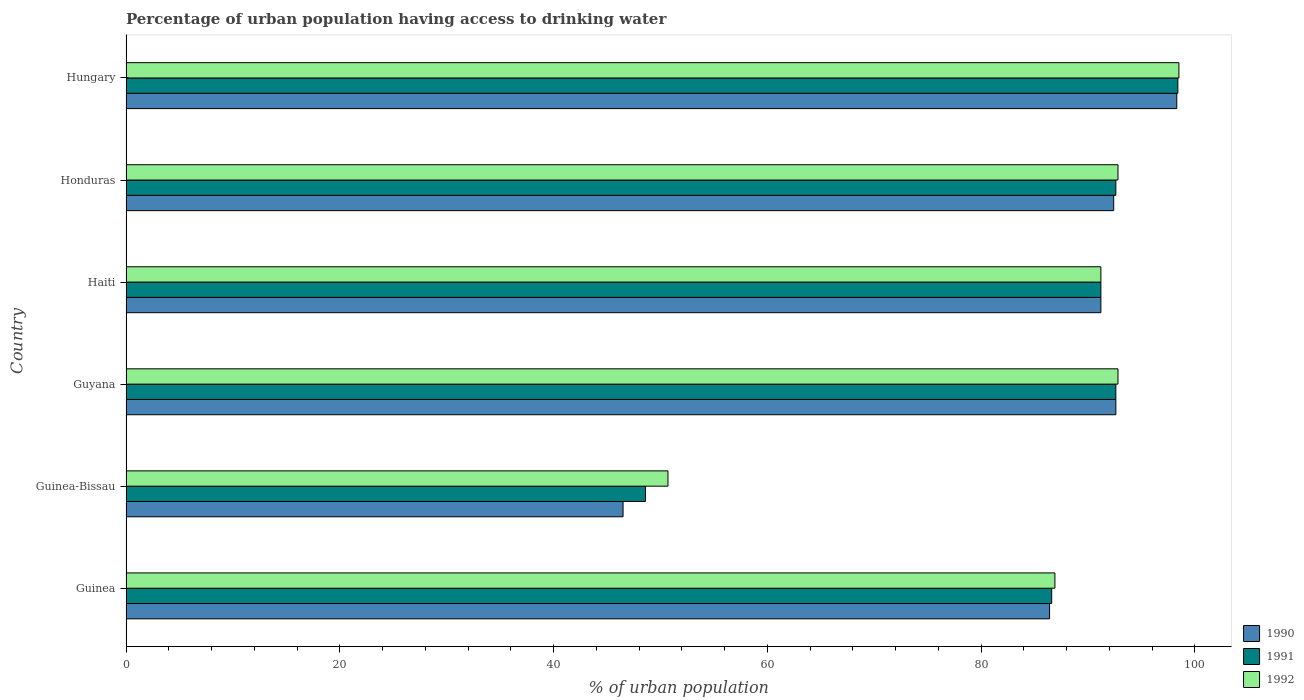How many groups of bars are there?
Your answer should be very brief. 6. Are the number of bars on each tick of the Y-axis equal?
Provide a succinct answer. Yes. What is the label of the 4th group of bars from the top?
Make the answer very short. Guyana. In how many cases, is the number of bars for a given country not equal to the number of legend labels?
Provide a succinct answer. 0. What is the percentage of urban population having access to drinking water in 1990 in Guinea?
Ensure brevity in your answer.  86.4. Across all countries, what is the maximum percentage of urban population having access to drinking water in 1991?
Offer a very short reply. 98.4. Across all countries, what is the minimum percentage of urban population having access to drinking water in 1990?
Provide a short and direct response. 46.5. In which country was the percentage of urban population having access to drinking water in 1991 maximum?
Make the answer very short. Hungary. In which country was the percentage of urban population having access to drinking water in 1990 minimum?
Your response must be concise. Guinea-Bissau. What is the total percentage of urban population having access to drinking water in 1991 in the graph?
Make the answer very short. 510. What is the difference between the percentage of urban population having access to drinking water in 1991 in Guinea and that in Honduras?
Your answer should be very brief. -6. What is the difference between the percentage of urban population having access to drinking water in 1990 in Guinea-Bissau and the percentage of urban population having access to drinking water in 1991 in Haiti?
Ensure brevity in your answer.  -44.7. What is the average percentage of urban population having access to drinking water in 1992 per country?
Your answer should be very brief. 85.48. In how many countries, is the percentage of urban population having access to drinking water in 1990 greater than 48 %?
Give a very brief answer. 5. What is the ratio of the percentage of urban population having access to drinking water in 1991 in Guinea-Bissau to that in Honduras?
Your response must be concise. 0.52. What is the difference between the highest and the second highest percentage of urban population having access to drinking water in 1991?
Ensure brevity in your answer.  5.8. What is the difference between the highest and the lowest percentage of urban population having access to drinking water in 1990?
Provide a succinct answer. 51.8. In how many countries, is the percentage of urban population having access to drinking water in 1991 greater than the average percentage of urban population having access to drinking water in 1991 taken over all countries?
Your response must be concise. 5. Is the sum of the percentage of urban population having access to drinking water in 1990 in Guinea-Bissau and Guyana greater than the maximum percentage of urban population having access to drinking water in 1991 across all countries?
Your answer should be very brief. Yes. What does the 2nd bar from the top in Haiti represents?
Make the answer very short. 1991. Are all the bars in the graph horizontal?
Your answer should be very brief. Yes. How many countries are there in the graph?
Your answer should be compact. 6. Are the values on the major ticks of X-axis written in scientific E-notation?
Your answer should be very brief. No. Does the graph contain any zero values?
Give a very brief answer. No. Does the graph contain grids?
Your response must be concise. No. How are the legend labels stacked?
Keep it short and to the point. Vertical. What is the title of the graph?
Your answer should be very brief. Percentage of urban population having access to drinking water. What is the label or title of the X-axis?
Your answer should be compact. % of urban population. What is the % of urban population of 1990 in Guinea?
Provide a succinct answer. 86.4. What is the % of urban population in 1991 in Guinea?
Offer a very short reply. 86.6. What is the % of urban population of 1992 in Guinea?
Your answer should be compact. 86.9. What is the % of urban population in 1990 in Guinea-Bissau?
Offer a very short reply. 46.5. What is the % of urban population of 1991 in Guinea-Bissau?
Provide a succinct answer. 48.6. What is the % of urban population of 1992 in Guinea-Bissau?
Give a very brief answer. 50.7. What is the % of urban population of 1990 in Guyana?
Give a very brief answer. 92.6. What is the % of urban population of 1991 in Guyana?
Your response must be concise. 92.6. What is the % of urban population in 1992 in Guyana?
Offer a very short reply. 92.8. What is the % of urban population in 1990 in Haiti?
Ensure brevity in your answer.  91.2. What is the % of urban population of 1991 in Haiti?
Your response must be concise. 91.2. What is the % of urban population of 1992 in Haiti?
Give a very brief answer. 91.2. What is the % of urban population in 1990 in Honduras?
Your answer should be very brief. 92.4. What is the % of urban population of 1991 in Honduras?
Offer a very short reply. 92.6. What is the % of urban population of 1992 in Honduras?
Your answer should be compact. 92.8. What is the % of urban population of 1990 in Hungary?
Give a very brief answer. 98.3. What is the % of urban population of 1991 in Hungary?
Your answer should be very brief. 98.4. What is the % of urban population of 1992 in Hungary?
Provide a short and direct response. 98.5. Across all countries, what is the maximum % of urban population of 1990?
Your answer should be compact. 98.3. Across all countries, what is the maximum % of urban population of 1991?
Offer a very short reply. 98.4. Across all countries, what is the maximum % of urban population of 1992?
Keep it short and to the point. 98.5. Across all countries, what is the minimum % of urban population of 1990?
Provide a succinct answer. 46.5. Across all countries, what is the minimum % of urban population in 1991?
Offer a terse response. 48.6. Across all countries, what is the minimum % of urban population in 1992?
Offer a terse response. 50.7. What is the total % of urban population in 1990 in the graph?
Provide a short and direct response. 507.4. What is the total % of urban population of 1991 in the graph?
Make the answer very short. 510. What is the total % of urban population of 1992 in the graph?
Give a very brief answer. 512.9. What is the difference between the % of urban population of 1990 in Guinea and that in Guinea-Bissau?
Ensure brevity in your answer.  39.9. What is the difference between the % of urban population of 1992 in Guinea and that in Guinea-Bissau?
Keep it short and to the point. 36.2. What is the difference between the % of urban population in 1991 in Guinea and that in Guyana?
Keep it short and to the point. -6. What is the difference between the % of urban population of 1992 in Guinea and that in Haiti?
Make the answer very short. -4.3. What is the difference between the % of urban population of 1991 in Guinea and that in Hungary?
Keep it short and to the point. -11.8. What is the difference between the % of urban population in 1992 in Guinea and that in Hungary?
Your answer should be compact. -11.6. What is the difference between the % of urban population in 1990 in Guinea-Bissau and that in Guyana?
Offer a terse response. -46.1. What is the difference between the % of urban population in 1991 in Guinea-Bissau and that in Guyana?
Keep it short and to the point. -44. What is the difference between the % of urban population in 1992 in Guinea-Bissau and that in Guyana?
Your answer should be very brief. -42.1. What is the difference between the % of urban population of 1990 in Guinea-Bissau and that in Haiti?
Your response must be concise. -44.7. What is the difference between the % of urban population of 1991 in Guinea-Bissau and that in Haiti?
Make the answer very short. -42.6. What is the difference between the % of urban population in 1992 in Guinea-Bissau and that in Haiti?
Your answer should be very brief. -40.5. What is the difference between the % of urban population of 1990 in Guinea-Bissau and that in Honduras?
Offer a very short reply. -45.9. What is the difference between the % of urban population in 1991 in Guinea-Bissau and that in Honduras?
Provide a short and direct response. -44. What is the difference between the % of urban population in 1992 in Guinea-Bissau and that in Honduras?
Your answer should be very brief. -42.1. What is the difference between the % of urban population of 1990 in Guinea-Bissau and that in Hungary?
Your answer should be very brief. -51.8. What is the difference between the % of urban population of 1991 in Guinea-Bissau and that in Hungary?
Make the answer very short. -49.8. What is the difference between the % of urban population in 1992 in Guinea-Bissau and that in Hungary?
Provide a short and direct response. -47.8. What is the difference between the % of urban population of 1990 in Guyana and that in Haiti?
Keep it short and to the point. 1.4. What is the difference between the % of urban population in 1990 in Guyana and that in Honduras?
Your answer should be compact. 0.2. What is the difference between the % of urban population of 1992 in Guyana and that in Honduras?
Your answer should be very brief. 0. What is the difference between the % of urban population in 1992 in Guyana and that in Hungary?
Offer a very short reply. -5.7. What is the difference between the % of urban population in 1990 in Haiti and that in Hungary?
Give a very brief answer. -7.1. What is the difference between the % of urban population of 1991 in Haiti and that in Hungary?
Ensure brevity in your answer.  -7.2. What is the difference between the % of urban population of 1990 in Honduras and that in Hungary?
Give a very brief answer. -5.9. What is the difference between the % of urban population of 1991 in Honduras and that in Hungary?
Your answer should be compact. -5.8. What is the difference between the % of urban population of 1992 in Honduras and that in Hungary?
Make the answer very short. -5.7. What is the difference between the % of urban population in 1990 in Guinea and the % of urban population in 1991 in Guinea-Bissau?
Your answer should be compact. 37.8. What is the difference between the % of urban population in 1990 in Guinea and the % of urban population in 1992 in Guinea-Bissau?
Your answer should be compact. 35.7. What is the difference between the % of urban population in 1991 in Guinea and the % of urban population in 1992 in Guinea-Bissau?
Your answer should be compact. 35.9. What is the difference between the % of urban population of 1990 in Guinea and the % of urban population of 1991 in Haiti?
Provide a succinct answer. -4.8. What is the difference between the % of urban population of 1990 in Guinea and the % of urban population of 1992 in Haiti?
Offer a terse response. -4.8. What is the difference between the % of urban population in 1991 in Guinea and the % of urban population in 1992 in Haiti?
Ensure brevity in your answer.  -4.6. What is the difference between the % of urban population of 1990 in Guinea and the % of urban population of 1991 in Honduras?
Give a very brief answer. -6.2. What is the difference between the % of urban population in 1991 in Guinea and the % of urban population in 1992 in Hungary?
Make the answer very short. -11.9. What is the difference between the % of urban population in 1990 in Guinea-Bissau and the % of urban population in 1991 in Guyana?
Your response must be concise. -46.1. What is the difference between the % of urban population in 1990 in Guinea-Bissau and the % of urban population in 1992 in Guyana?
Keep it short and to the point. -46.3. What is the difference between the % of urban population of 1991 in Guinea-Bissau and the % of urban population of 1992 in Guyana?
Your answer should be compact. -44.2. What is the difference between the % of urban population in 1990 in Guinea-Bissau and the % of urban population in 1991 in Haiti?
Provide a succinct answer. -44.7. What is the difference between the % of urban population of 1990 in Guinea-Bissau and the % of urban population of 1992 in Haiti?
Make the answer very short. -44.7. What is the difference between the % of urban population of 1991 in Guinea-Bissau and the % of urban population of 1992 in Haiti?
Make the answer very short. -42.6. What is the difference between the % of urban population in 1990 in Guinea-Bissau and the % of urban population in 1991 in Honduras?
Ensure brevity in your answer.  -46.1. What is the difference between the % of urban population of 1990 in Guinea-Bissau and the % of urban population of 1992 in Honduras?
Your answer should be compact. -46.3. What is the difference between the % of urban population in 1991 in Guinea-Bissau and the % of urban population in 1992 in Honduras?
Your answer should be compact. -44.2. What is the difference between the % of urban population in 1990 in Guinea-Bissau and the % of urban population in 1991 in Hungary?
Keep it short and to the point. -51.9. What is the difference between the % of urban population in 1990 in Guinea-Bissau and the % of urban population in 1992 in Hungary?
Provide a short and direct response. -52. What is the difference between the % of urban population of 1991 in Guinea-Bissau and the % of urban population of 1992 in Hungary?
Ensure brevity in your answer.  -49.9. What is the difference between the % of urban population of 1990 in Guyana and the % of urban population of 1991 in Haiti?
Provide a short and direct response. 1.4. What is the difference between the % of urban population in 1990 in Guyana and the % of urban population in 1991 in Honduras?
Ensure brevity in your answer.  0. What is the difference between the % of urban population of 1991 in Guyana and the % of urban population of 1992 in Honduras?
Keep it short and to the point. -0.2. What is the difference between the % of urban population in 1991 in Guyana and the % of urban population in 1992 in Hungary?
Your answer should be compact. -5.9. What is the difference between the % of urban population in 1990 in Haiti and the % of urban population in 1991 in Honduras?
Your response must be concise. -1.4. What is the difference between the % of urban population of 1990 in Haiti and the % of urban population of 1991 in Hungary?
Ensure brevity in your answer.  -7.2. What is the difference between the % of urban population in 1990 in Honduras and the % of urban population in 1991 in Hungary?
Offer a very short reply. -6. What is the average % of urban population of 1990 per country?
Your response must be concise. 84.57. What is the average % of urban population of 1992 per country?
Provide a short and direct response. 85.48. What is the difference between the % of urban population of 1990 and % of urban population of 1992 in Guinea?
Your answer should be compact. -0.5. What is the difference between the % of urban population of 1990 and % of urban population of 1991 in Guyana?
Provide a succinct answer. 0. What is the difference between the % of urban population in 1990 and % of urban population in 1992 in Haiti?
Provide a succinct answer. 0. What is the difference between the % of urban population in 1991 and % of urban population in 1992 in Haiti?
Offer a terse response. 0. What is the difference between the % of urban population of 1990 and % of urban population of 1992 in Honduras?
Offer a very short reply. -0.4. What is the ratio of the % of urban population in 1990 in Guinea to that in Guinea-Bissau?
Provide a succinct answer. 1.86. What is the ratio of the % of urban population of 1991 in Guinea to that in Guinea-Bissau?
Offer a very short reply. 1.78. What is the ratio of the % of urban population of 1992 in Guinea to that in Guinea-Bissau?
Provide a short and direct response. 1.71. What is the ratio of the % of urban population of 1990 in Guinea to that in Guyana?
Keep it short and to the point. 0.93. What is the ratio of the % of urban population in 1991 in Guinea to that in Guyana?
Provide a short and direct response. 0.94. What is the ratio of the % of urban population in 1992 in Guinea to that in Guyana?
Provide a succinct answer. 0.94. What is the ratio of the % of urban population in 1990 in Guinea to that in Haiti?
Make the answer very short. 0.95. What is the ratio of the % of urban population of 1991 in Guinea to that in Haiti?
Keep it short and to the point. 0.95. What is the ratio of the % of urban population in 1992 in Guinea to that in Haiti?
Give a very brief answer. 0.95. What is the ratio of the % of urban population in 1990 in Guinea to that in Honduras?
Ensure brevity in your answer.  0.94. What is the ratio of the % of urban population in 1991 in Guinea to that in Honduras?
Offer a very short reply. 0.94. What is the ratio of the % of urban population of 1992 in Guinea to that in Honduras?
Provide a short and direct response. 0.94. What is the ratio of the % of urban population of 1990 in Guinea to that in Hungary?
Ensure brevity in your answer.  0.88. What is the ratio of the % of urban population of 1991 in Guinea to that in Hungary?
Provide a succinct answer. 0.88. What is the ratio of the % of urban population of 1992 in Guinea to that in Hungary?
Make the answer very short. 0.88. What is the ratio of the % of urban population in 1990 in Guinea-Bissau to that in Guyana?
Your answer should be very brief. 0.5. What is the ratio of the % of urban population of 1991 in Guinea-Bissau to that in Guyana?
Your response must be concise. 0.52. What is the ratio of the % of urban population in 1992 in Guinea-Bissau to that in Guyana?
Your answer should be compact. 0.55. What is the ratio of the % of urban population of 1990 in Guinea-Bissau to that in Haiti?
Your answer should be compact. 0.51. What is the ratio of the % of urban population of 1991 in Guinea-Bissau to that in Haiti?
Offer a terse response. 0.53. What is the ratio of the % of urban population of 1992 in Guinea-Bissau to that in Haiti?
Give a very brief answer. 0.56. What is the ratio of the % of urban population of 1990 in Guinea-Bissau to that in Honduras?
Your answer should be compact. 0.5. What is the ratio of the % of urban population in 1991 in Guinea-Bissau to that in Honduras?
Your answer should be compact. 0.52. What is the ratio of the % of urban population of 1992 in Guinea-Bissau to that in Honduras?
Provide a short and direct response. 0.55. What is the ratio of the % of urban population of 1990 in Guinea-Bissau to that in Hungary?
Ensure brevity in your answer.  0.47. What is the ratio of the % of urban population of 1991 in Guinea-Bissau to that in Hungary?
Your response must be concise. 0.49. What is the ratio of the % of urban population of 1992 in Guinea-Bissau to that in Hungary?
Offer a terse response. 0.51. What is the ratio of the % of urban population of 1990 in Guyana to that in Haiti?
Provide a succinct answer. 1.02. What is the ratio of the % of urban population in 1991 in Guyana to that in Haiti?
Your answer should be very brief. 1.02. What is the ratio of the % of urban population in 1992 in Guyana to that in Haiti?
Offer a very short reply. 1.02. What is the ratio of the % of urban population in 1990 in Guyana to that in Honduras?
Your response must be concise. 1. What is the ratio of the % of urban population of 1991 in Guyana to that in Honduras?
Ensure brevity in your answer.  1. What is the ratio of the % of urban population of 1992 in Guyana to that in Honduras?
Your answer should be compact. 1. What is the ratio of the % of urban population of 1990 in Guyana to that in Hungary?
Provide a short and direct response. 0.94. What is the ratio of the % of urban population in 1991 in Guyana to that in Hungary?
Your response must be concise. 0.94. What is the ratio of the % of urban population of 1992 in Guyana to that in Hungary?
Make the answer very short. 0.94. What is the ratio of the % of urban population of 1991 in Haiti to that in Honduras?
Keep it short and to the point. 0.98. What is the ratio of the % of urban population of 1992 in Haiti to that in Honduras?
Provide a short and direct response. 0.98. What is the ratio of the % of urban population of 1990 in Haiti to that in Hungary?
Provide a succinct answer. 0.93. What is the ratio of the % of urban population in 1991 in Haiti to that in Hungary?
Provide a short and direct response. 0.93. What is the ratio of the % of urban population in 1992 in Haiti to that in Hungary?
Provide a short and direct response. 0.93. What is the ratio of the % of urban population of 1991 in Honduras to that in Hungary?
Ensure brevity in your answer.  0.94. What is the ratio of the % of urban population of 1992 in Honduras to that in Hungary?
Keep it short and to the point. 0.94. What is the difference between the highest and the second highest % of urban population in 1991?
Offer a very short reply. 5.8. What is the difference between the highest and the second highest % of urban population in 1992?
Make the answer very short. 5.7. What is the difference between the highest and the lowest % of urban population of 1990?
Your answer should be compact. 51.8. What is the difference between the highest and the lowest % of urban population in 1991?
Keep it short and to the point. 49.8. What is the difference between the highest and the lowest % of urban population in 1992?
Make the answer very short. 47.8. 